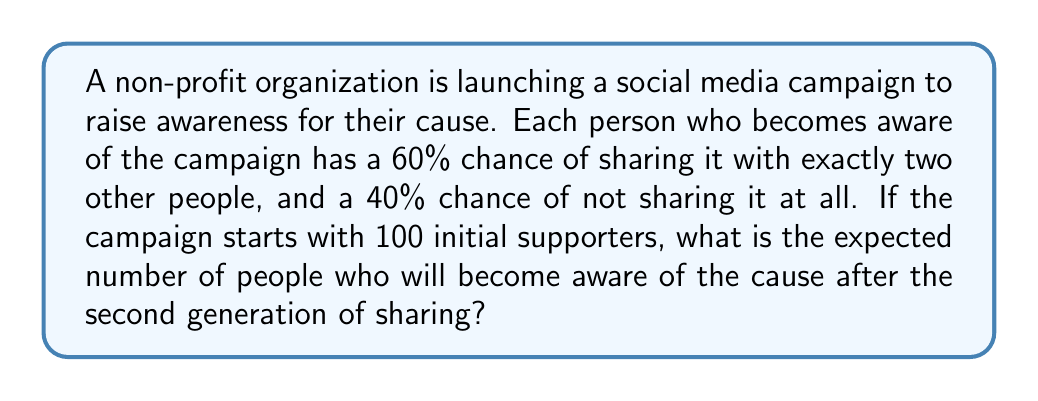What is the answer to this math problem? Let's approach this problem step-by-step using a branching process model:

1) First, let's define our variables:
   $X_0 = 100$ (initial supporters)
   $p = 0.6$ (probability of sharing)
   $m = 2$ (number of people each supporter shares with)

2) In a branching process, the expected number of offspring (new awareness) per individual is:
   $\mu = p \cdot m = 0.6 \cdot 2 = 1.2$

3) The expected number of people aware after the first generation is:
   $E[X_1] = X_0 \cdot \mu = 100 \cdot 1.2 = 120$

4) For the second generation, we apply the same principle to the expected number from the first generation:
   $E[X_2] = E[X_1] \cdot \mu = 120 \cdot 1.2 = 144$

5) The total number of people aware after the second generation includes the initial supporters, those from the first generation, and those from the second generation:
   $E[Total] = X_0 + E[X_1] + E[X_2] = 100 + 120 + 144 = 364$

Therefore, the expected number of people aware of the cause after the second generation of sharing is 364.
Answer: 364 people 